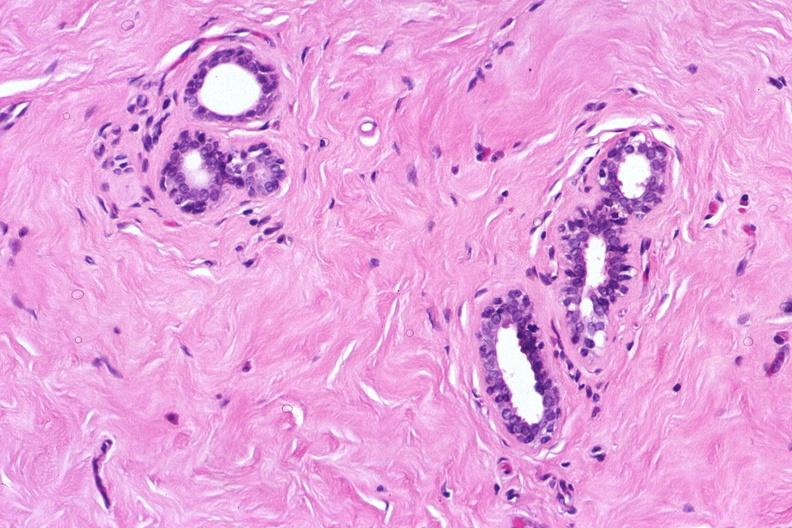what is present?
Answer the question using a single word or phrase. Female reproductive 